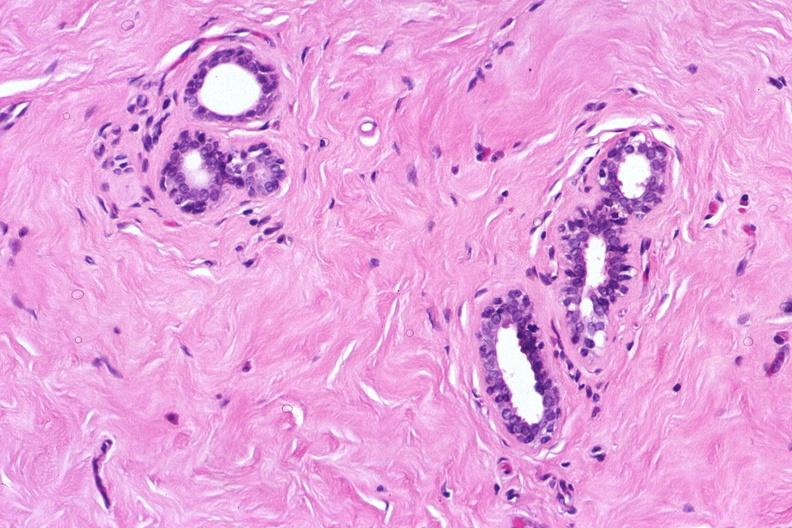what is present?
Answer the question using a single word or phrase. Female reproductive 